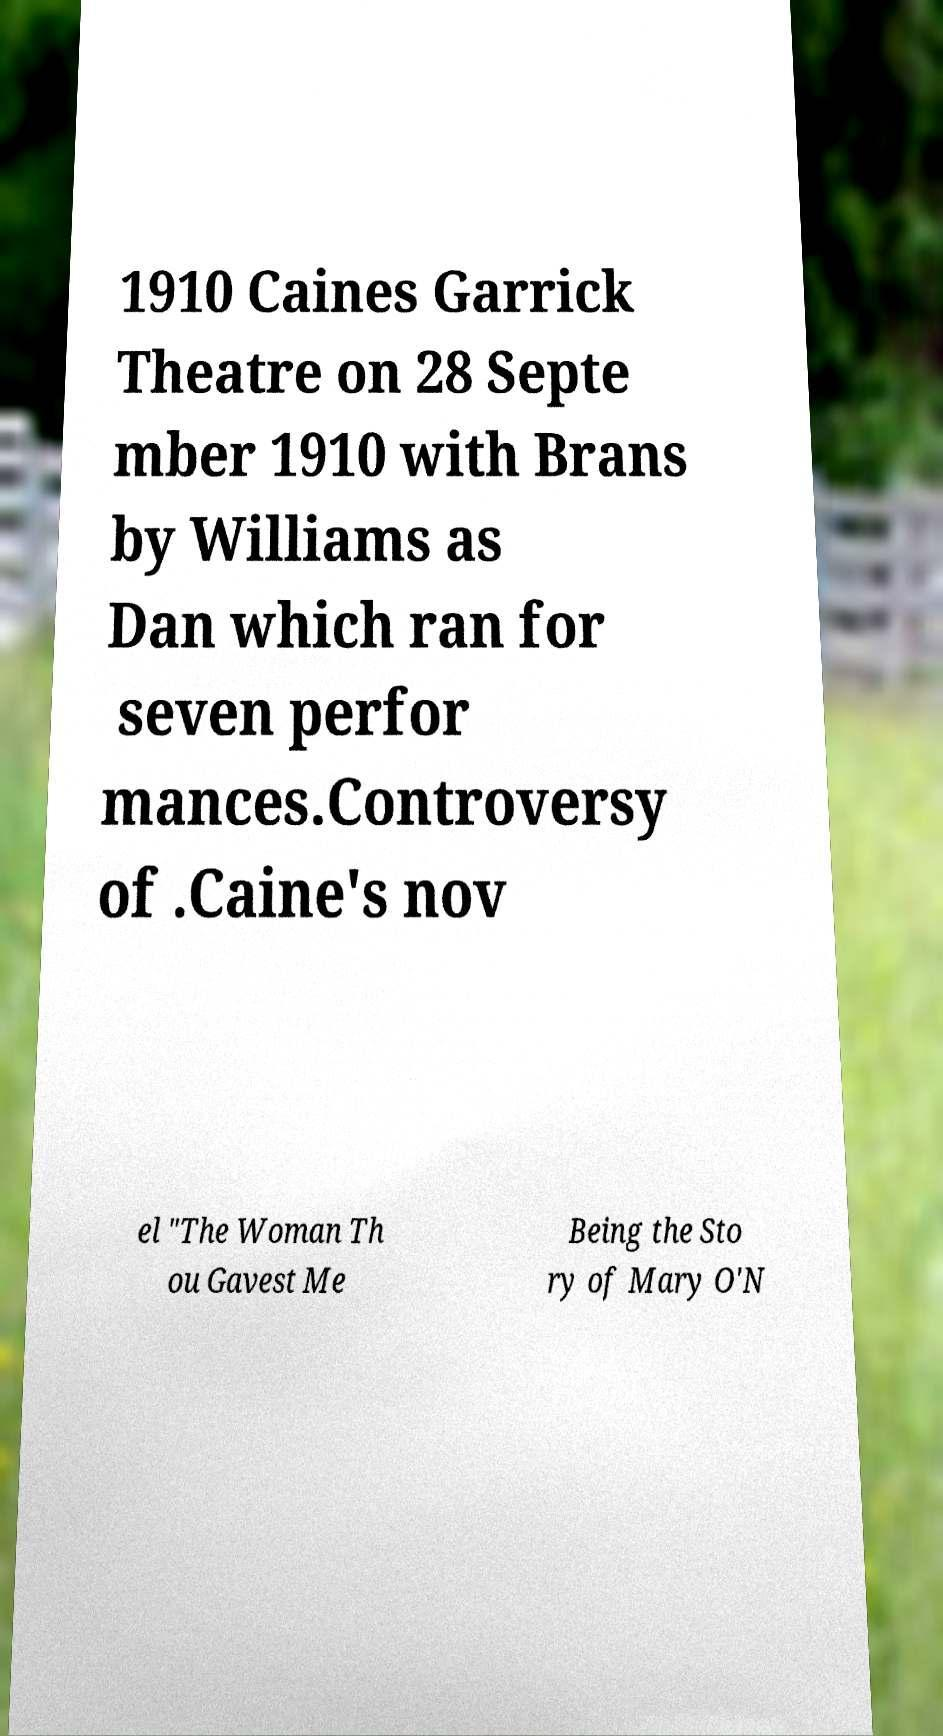Could you extract and type out the text from this image? 1910 Caines Garrick Theatre on 28 Septe mber 1910 with Brans by Williams as Dan which ran for seven perfor mances.Controversy of .Caine's nov el "The Woman Th ou Gavest Me Being the Sto ry of Mary O'N 